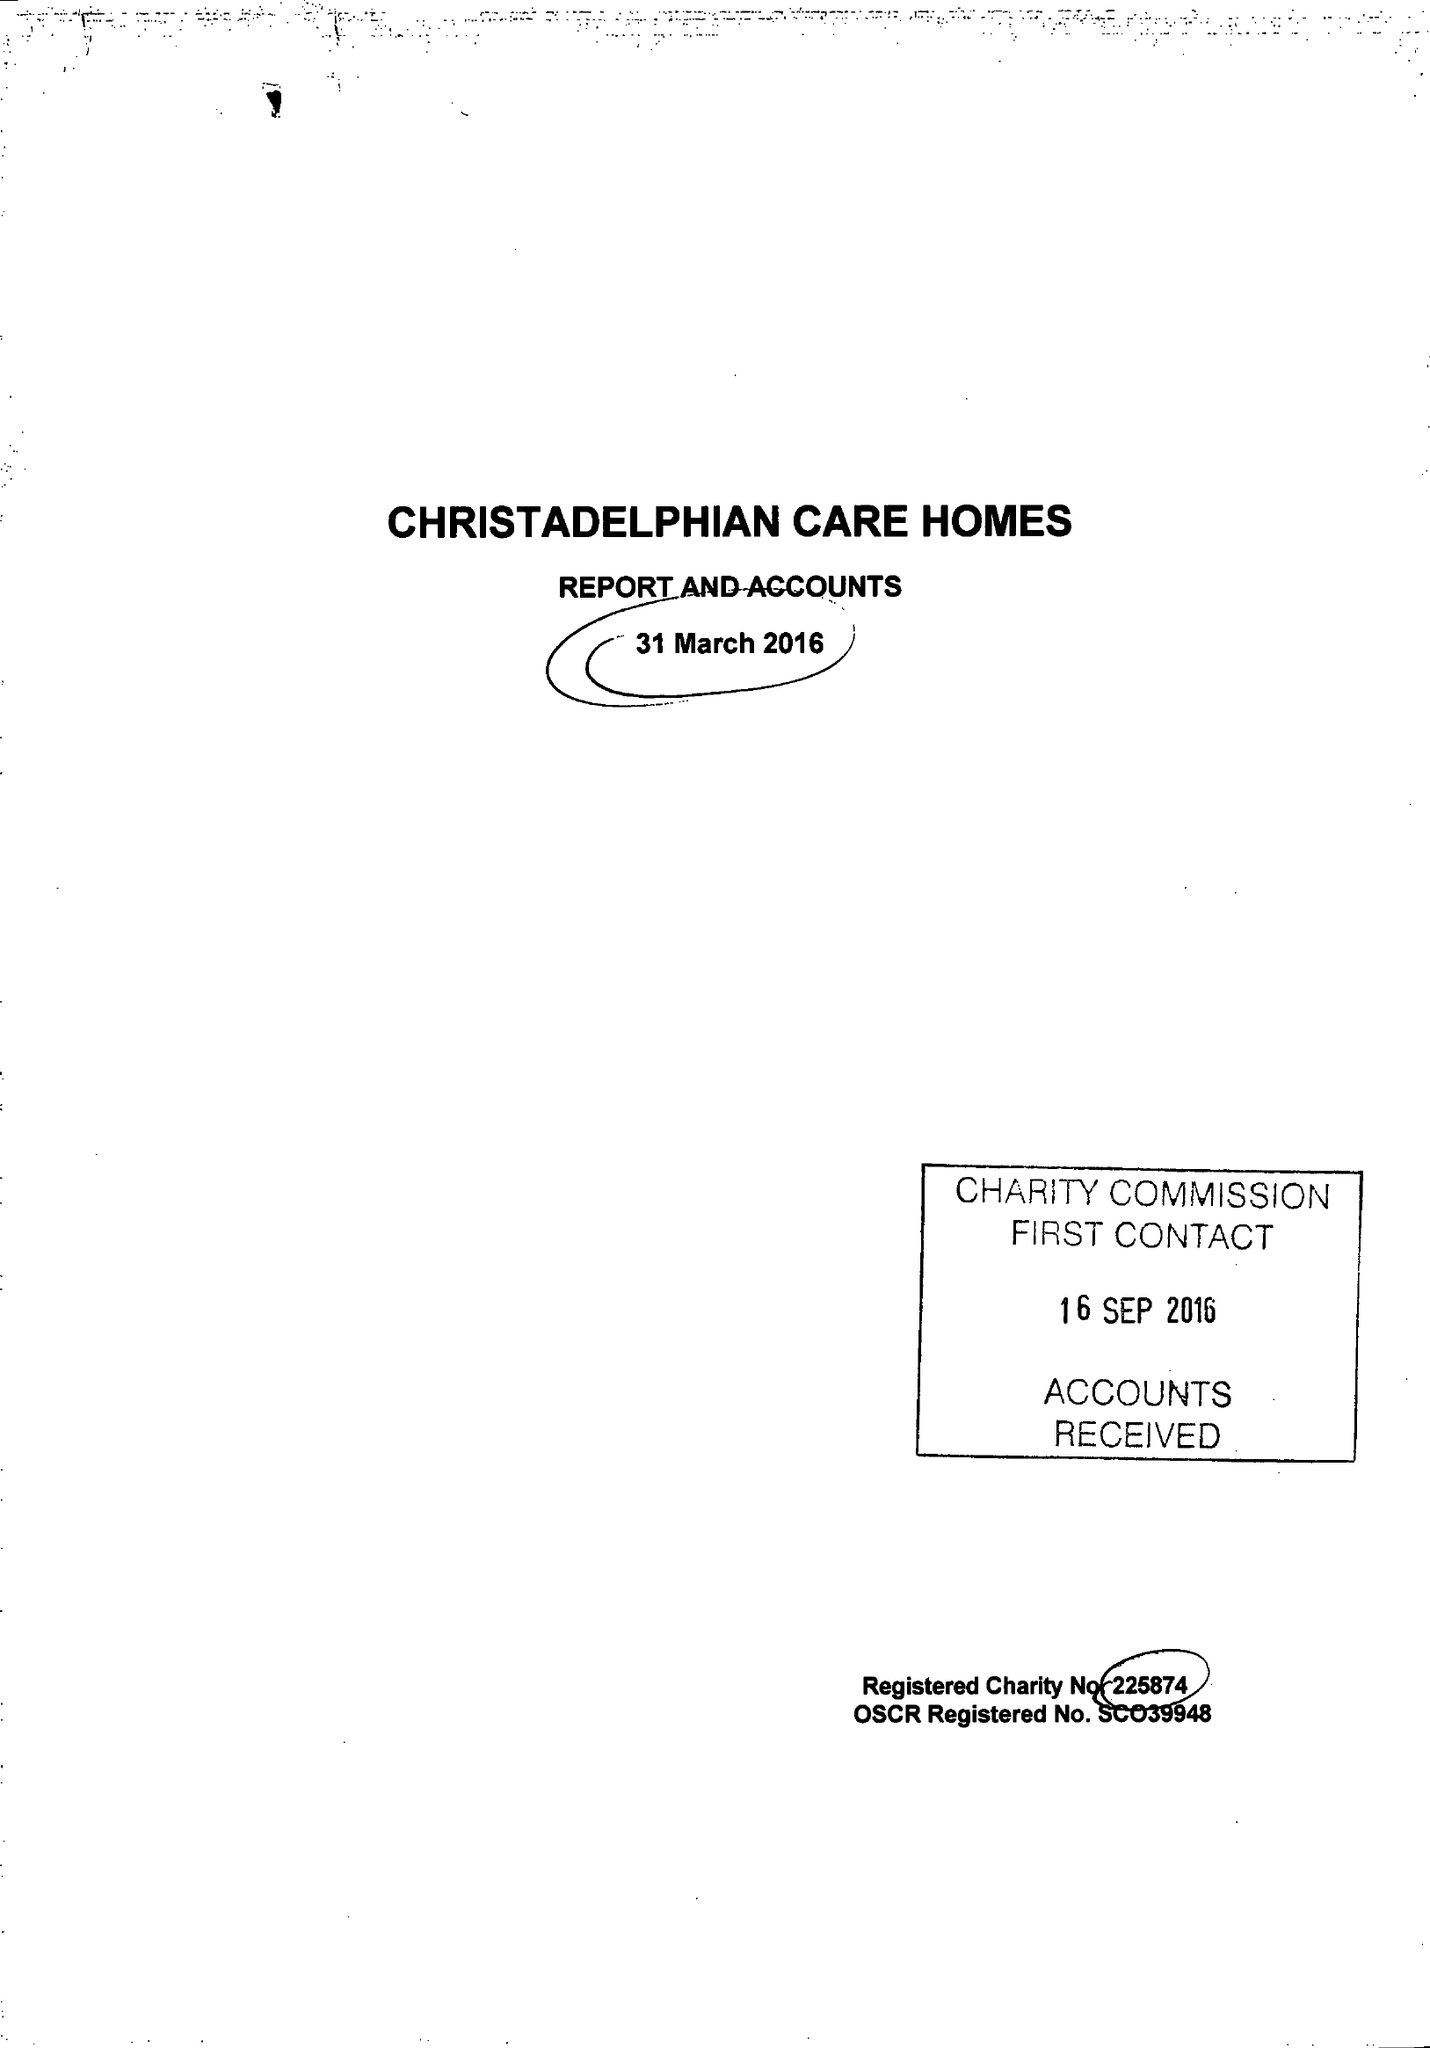What is the value for the spending_annually_in_british_pounds?
Answer the question using a single word or phrase. 9300080.00 